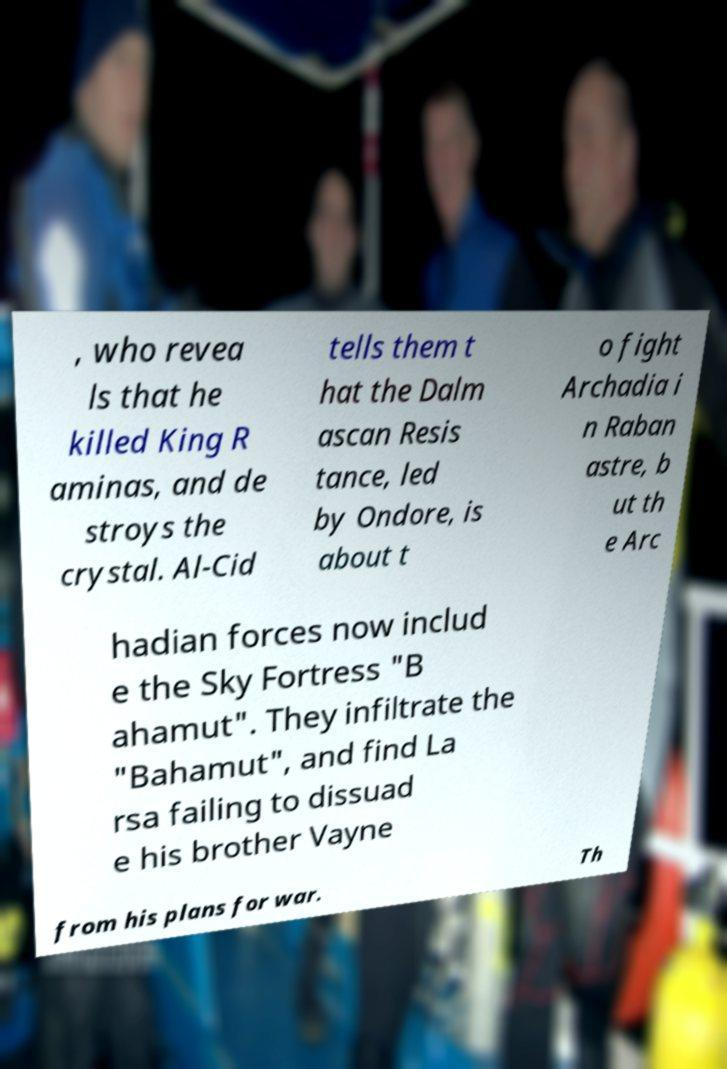Can you read and provide the text displayed in the image?This photo seems to have some interesting text. Can you extract and type it out for me? , who revea ls that he killed King R aminas, and de stroys the crystal. Al-Cid tells them t hat the Dalm ascan Resis tance, led by Ondore, is about t o fight Archadia i n Raban astre, b ut th e Arc hadian forces now includ e the Sky Fortress "B ahamut". They infiltrate the "Bahamut", and find La rsa failing to dissuad e his brother Vayne from his plans for war. Th 